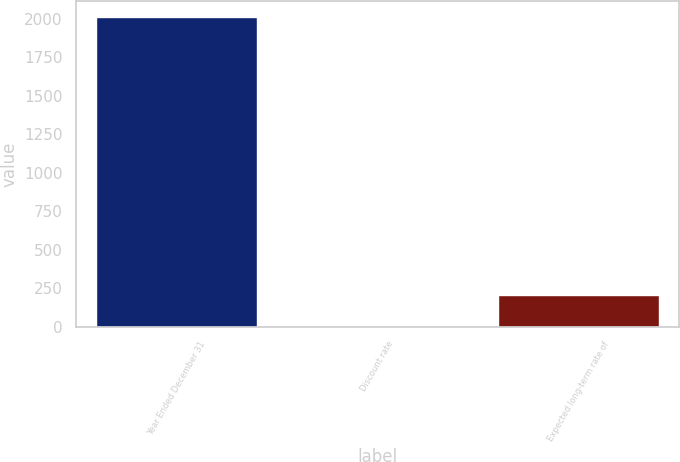Convert chart to OTSL. <chart><loc_0><loc_0><loc_500><loc_500><bar_chart><fcel>Year Ended December 31<fcel>Discount rate<fcel>Expected long-term rate of<nl><fcel>2015<fcel>3.75<fcel>204.88<nl></chart> 